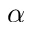Convert formula to latex. <formula><loc_0><loc_0><loc_500><loc_500>\alpha</formula> 